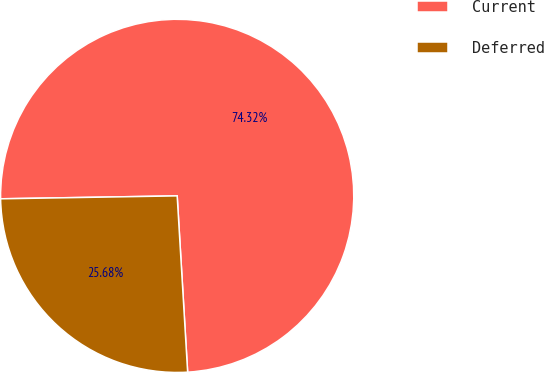<chart> <loc_0><loc_0><loc_500><loc_500><pie_chart><fcel>Current<fcel>Deferred<nl><fcel>74.32%<fcel>25.68%<nl></chart> 